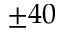<formula> <loc_0><loc_0><loc_500><loc_500>\pm 4 0</formula> 